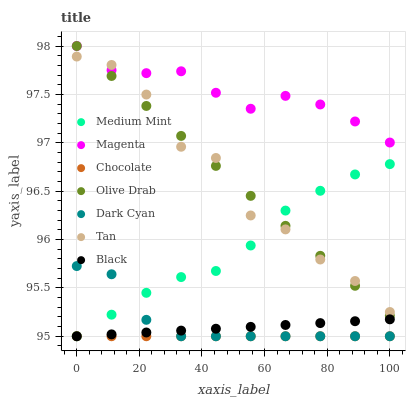Does Chocolate have the minimum area under the curve?
Answer yes or no. Yes. Does Magenta have the maximum area under the curve?
Answer yes or no. Yes. Does Black have the minimum area under the curve?
Answer yes or no. No. Does Black have the maximum area under the curve?
Answer yes or no. No. Is Chocolate the smoothest?
Answer yes or no. Yes. Is Tan the roughest?
Answer yes or no. Yes. Is Black the smoothest?
Answer yes or no. No. Is Black the roughest?
Answer yes or no. No. Does Medium Mint have the lowest value?
Answer yes or no. Yes. Does Magenta have the lowest value?
Answer yes or no. No. Does Olive Drab have the highest value?
Answer yes or no. Yes. Does Black have the highest value?
Answer yes or no. No. Is Black less than Tan?
Answer yes or no. Yes. Is Olive Drab greater than Chocolate?
Answer yes or no. Yes. Does Black intersect Chocolate?
Answer yes or no. Yes. Is Black less than Chocolate?
Answer yes or no. No. Is Black greater than Chocolate?
Answer yes or no. No. Does Black intersect Tan?
Answer yes or no. No. 